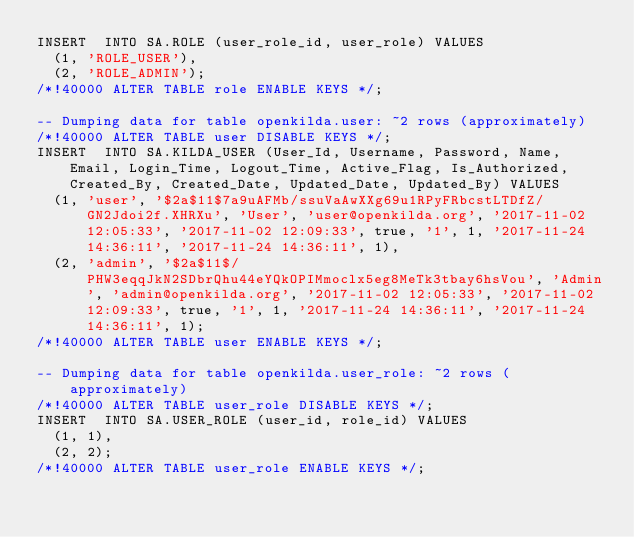<code> <loc_0><loc_0><loc_500><loc_500><_SQL_>INSERT  INTO SA.ROLE (user_role_id, user_role) VALUES
	(1, 'ROLE_USER'),
	(2, 'ROLE_ADMIN');
/*!40000 ALTER TABLE role ENABLE KEYS */;

-- Dumping data for table openkilda.user: ~2 rows (approximately)
/*!40000 ALTER TABLE user DISABLE KEYS */;
INSERT  INTO SA.KILDA_USER (User_Id, Username, Password, Name, Email, Login_Time, Logout_Time, Active_Flag, Is_Authorized, Created_By, Created_Date, Updated_Date, Updated_By) VALUES
	(1, 'user', '$2a$11$7a9uAFMb/ssuVaAwXXg69u1RPyFRbcstLTDfZ/GN2Jdoi2f.XHRXu', 'User', 'user@openkilda.org', '2017-11-02 12:05:33', '2017-11-02 12:09:33', true, '1', 1, '2017-11-24 14:36:11', '2017-11-24 14:36:11', 1),
	(2, 'admin', '$2a$11$/PHW3eqqJkN2SDbrQhu44eYQkOPIMmoclx5eg8MeTk3tbay6hsVou', 'Admin', 'admin@openkilda.org', '2017-11-02 12:05:33', '2017-11-02 12:09:33', true, '1', 1, '2017-11-24 14:36:11', '2017-11-24 14:36:11', 1);
/*!40000 ALTER TABLE user ENABLE KEYS */;

-- Dumping data for table openkilda.user_role: ~2 rows (approximately)
/*!40000 ALTER TABLE user_role DISABLE KEYS */;
INSERT  INTO SA.USER_ROLE (user_id, role_id) VALUES
	(1, 1),
	(2, 2);
/*!40000 ALTER TABLE user_role ENABLE KEYS */;</code> 